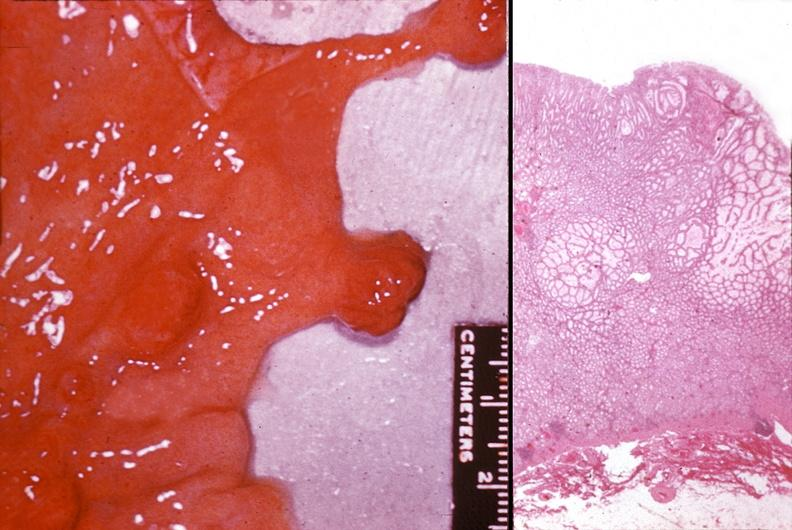does adrenal of premature 30 week gestation gram infant lesion show stomach, polyposis, multiple?
Answer the question using a single word or phrase. No 